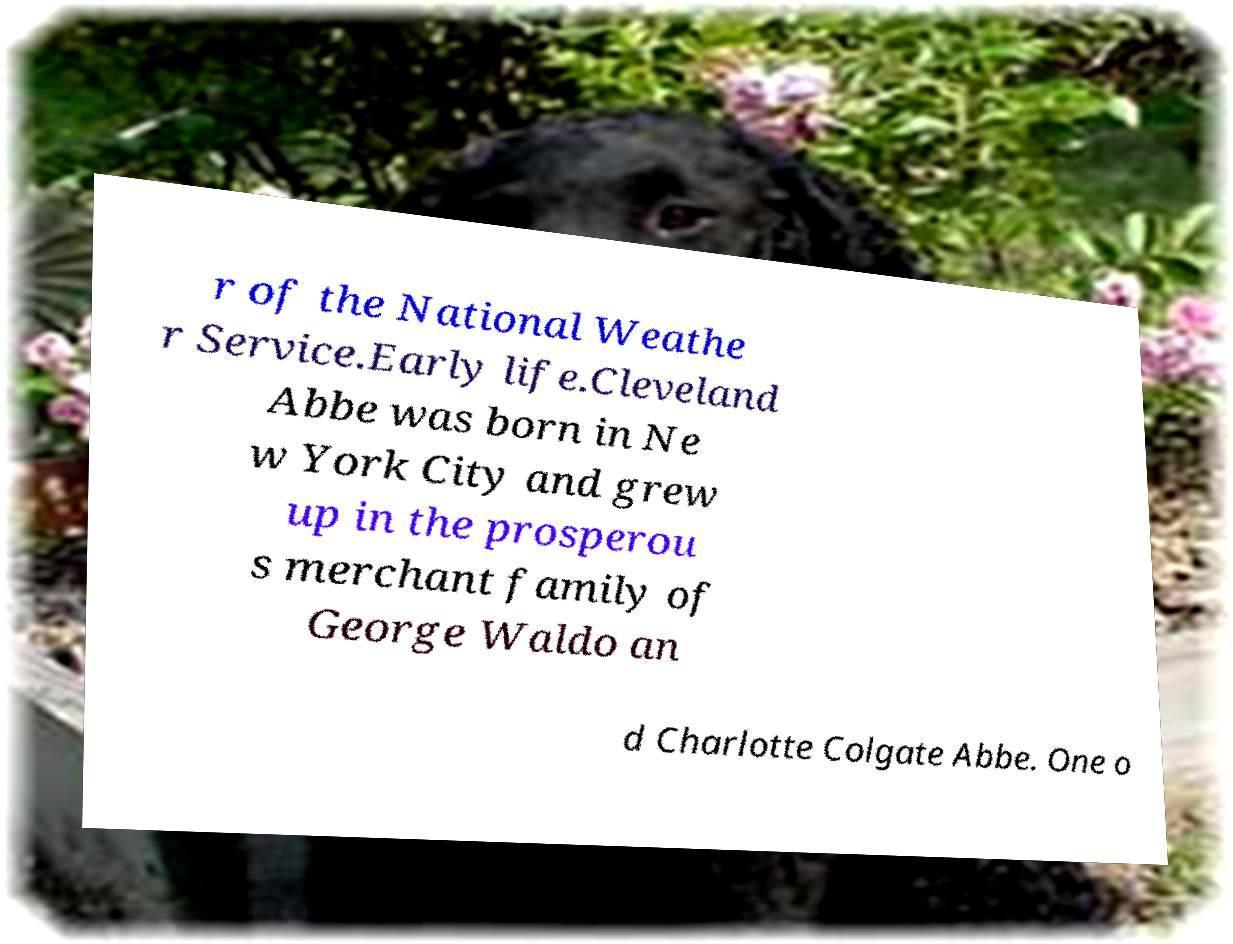Can you read and provide the text displayed in the image?This photo seems to have some interesting text. Can you extract and type it out for me? r of the National Weathe r Service.Early life.Cleveland Abbe was born in Ne w York City and grew up in the prosperou s merchant family of George Waldo an d Charlotte Colgate Abbe. One o 